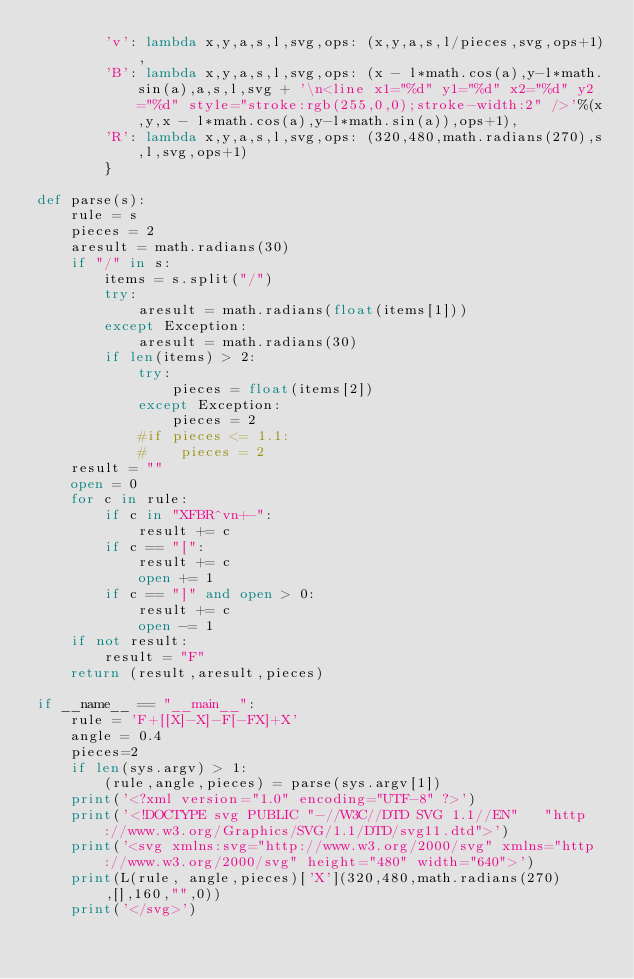<code> <loc_0><loc_0><loc_500><loc_500><_Python_>        'v': lambda x,y,a,s,l,svg,ops: (x,y,a,s,l/pieces,svg,ops+1),
        'B': lambda x,y,a,s,l,svg,ops: (x - l*math.cos(a),y-l*math.sin(a),a,s,l,svg + '\n<line x1="%d" y1="%d" x2="%d" y2="%d" style="stroke:rgb(255,0,0);stroke-width:2" />'%(x,y,x - l*math.cos(a),y-l*math.sin(a)),ops+1),
        'R': lambda x,y,a,s,l,svg,ops: (320,480,math.radians(270),s,l,svg,ops+1)
        }
        
def parse(s):
    rule = s
    pieces = 2
    aresult = math.radians(30)
    if "/" in s:
        items = s.split("/")
        try:
            aresult = math.radians(float(items[1]))
        except Exception:
            aresult = math.radians(30)
        if len(items) > 2:
            try:
                pieces = float(items[2])
            except Exception:
                pieces = 2
            #if pieces <= 1.1:
            #    pieces = 2
    result = ""
    open = 0
    for c in rule:
        if c in "XFBR^vn+-":
            result += c
        if c == "[":
            result += c 
            open += 1
        if c == "]" and open > 0:
            result += c
            open -= 1
    if not result:
        result = "F"
    return (result,aresult,pieces)

if __name__ == "__main__":
    rule = 'F+[[X]-X]-F[-FX]+X'
    angle = 0.4
    pieces=2
    if len(sys.argv) > 1:
        (rule,angle,pieces) = parse(sys.argv[1])
    print('<?xml version="1.0" encoding="UTF-8" ?>')
    print('<!DOCTYPE svg PUBLIC "-//W3C//DTD SVG 1.1//EN"   "http://www.w3.org/Graphics/SVG/1.1/DTD/svg11.dtd">')
    print('<svg xmlns:svg="http://www.w3.org/2000/svg" xmlns="http://www.w3.org/2000/svg" height="480" width="640">') 
    print(L(rule, angle,pieces)['X'](320,480,math.radians(270),[],160,"",0))
    print('</svg>')</code> 